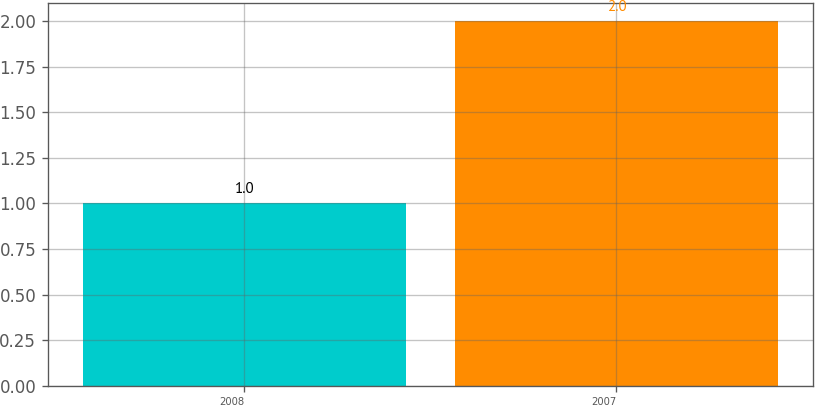<chart> <loc_0><loc_0><loc_500><loc_500><bar_chart><fcel>2008<fcel>2007<nl><fcel>1<fcel>2<nl></chart> 